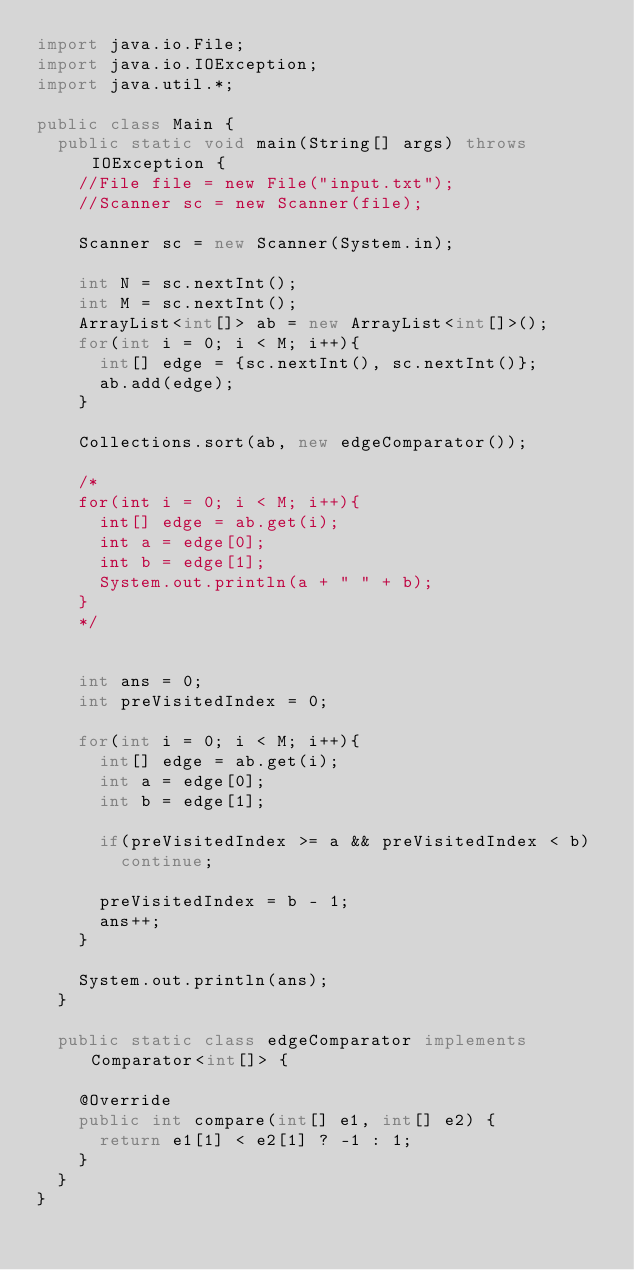<code> <loc_0><loc_0><loc_500><loc_500><_Java_>import java.io.File;
import java.io.IOException;
import java.util.*;
 
public class Main {
	public static void main(String[] args) throws IOException {
		//File file = new File("input.txt");
		//Scanner sc = new Scanner(file);
		
		Scanner sc = new Scanner(System.in);
		
		int N = sc.nextInt();
		int M = sc.nextInt();
		ArrayList<int[]> ab = new ArrayList<int[]>();
		for(int i = 0; i < M; i++){
			int[] edge = {sc.nextInt(), sc.nextInt()};
			ab.add(edge);
		}
		
		Collections.sort(ab, new edgeComparator());
		
		/*
		for(int i = 0; i < M; i++){
			int[] edge = ab.get(i);
			int a = edge[0];
			int b = edge[1];
			System.out.println(a + " " + b);
		}
		*/
		
		
		int ans = 0;
		int preVisitedIndex = 0;
		
		for(int i = 0; i < M; i++){
			int[] edge = ab.get(i);
			int a = edge[0];
			int b = edge[1];
			
			if(preVisitedIndex >= a && preVisitedIndex < b)
				continue;
			
			preVisitedIndex = b - 1;
			ans++;
		}
		
		System.out.println(ans);
	}
	
	public static class edgeComparator implements Comparator<int[]> {

		@Override
		public int compare(int[] e1, int[] e2) {
			return e1[1] < e2[1] ? -1 : 1;
		}
	}
}</code> 